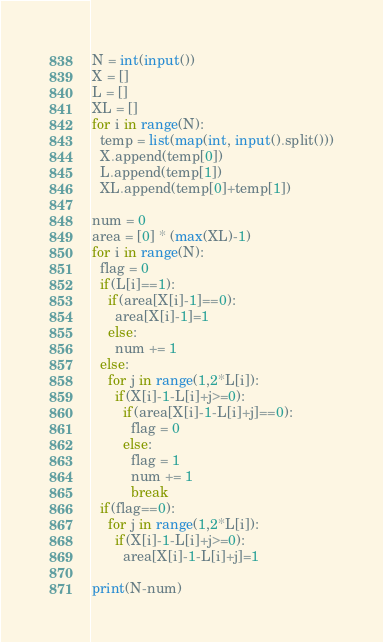<code> <loc_0><loc_0><loc_500><loc_500><_Python_>N = int(input())
X = []
L = []
XL = []
for i in range(N):
  temp = list(map(int, input().split()))
  X.append(temp[0])
  L.append(temp[1])
  XL.append(temp[0]+temp[1])
  
num = 0
area = [0] * (max(XL)-1)
for i in range(N):
  flag = 0
  if(L[i]==1):
    if(area[X[i]-1]==0):
      area[X[i]-1]=1
    else:
      num += 1
  else:
    for j in range(1,2*L[i]):
      if(X[i]-1-L[i]+j>=0):
        if(area[X[i]-1-L[i]+j]==0):
          flag = 0
        else:
          flag = 1
          num += 1
          break
  if(flag==0):
    for j in range(1,2*L[i]):
      if(X[i]-1-L[i]+j>=0):
        area[X[i]-1-L[i]+j]=1
    
print(N-num)</code> 